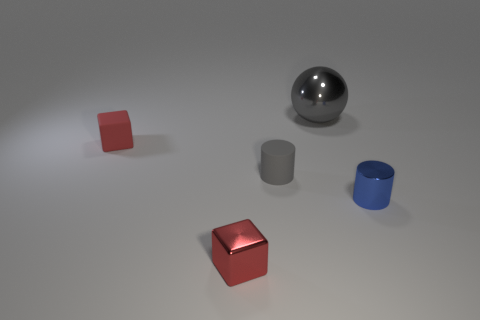Are there any other things that have the same material as the gray sphere?
Keep it short and to the point. Yes. The matte object that is the same color as the small metallic block is what size?
Ensure brevity in your answer.  Small. What is the material of the block behind the blue metal object?
Offer a very short reply. Rubber. Does the tiny shiny thing that is in front of the blue metallic cylinder have the same shape as the small rubber object that is on the right side of the red metal cube?
Give a very brief answer. No. There is another small block that is the same color as the tiny rubber cube; what material is it?
Offer a terse response. Metal. Is there a gray shiny thing?
Make the answer very short. Yes. What is the material of the other thing that is the same shape as the tiny red metal object?
Provide a succinct answer. Rubber. There is a metallic cylinder; are there any red things behind it?
Make the answer very short. Yes. Is the material of the cylinder that is behind the blue metal cylinder the same as the blue object?
Provide a short and direct response. No. Are there any tiny rubber cubes that have the same color as the small metal block?
Your answer should be compact. Yes. 